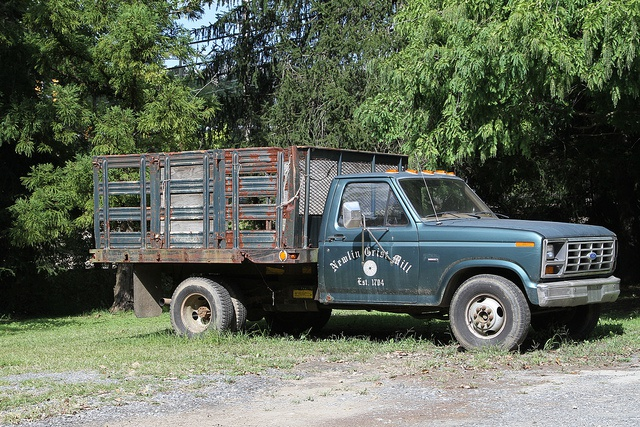Describe the objects in this image and their specific colors. I can see a truck in black, gray, darkgray, and blue tones in this image. 